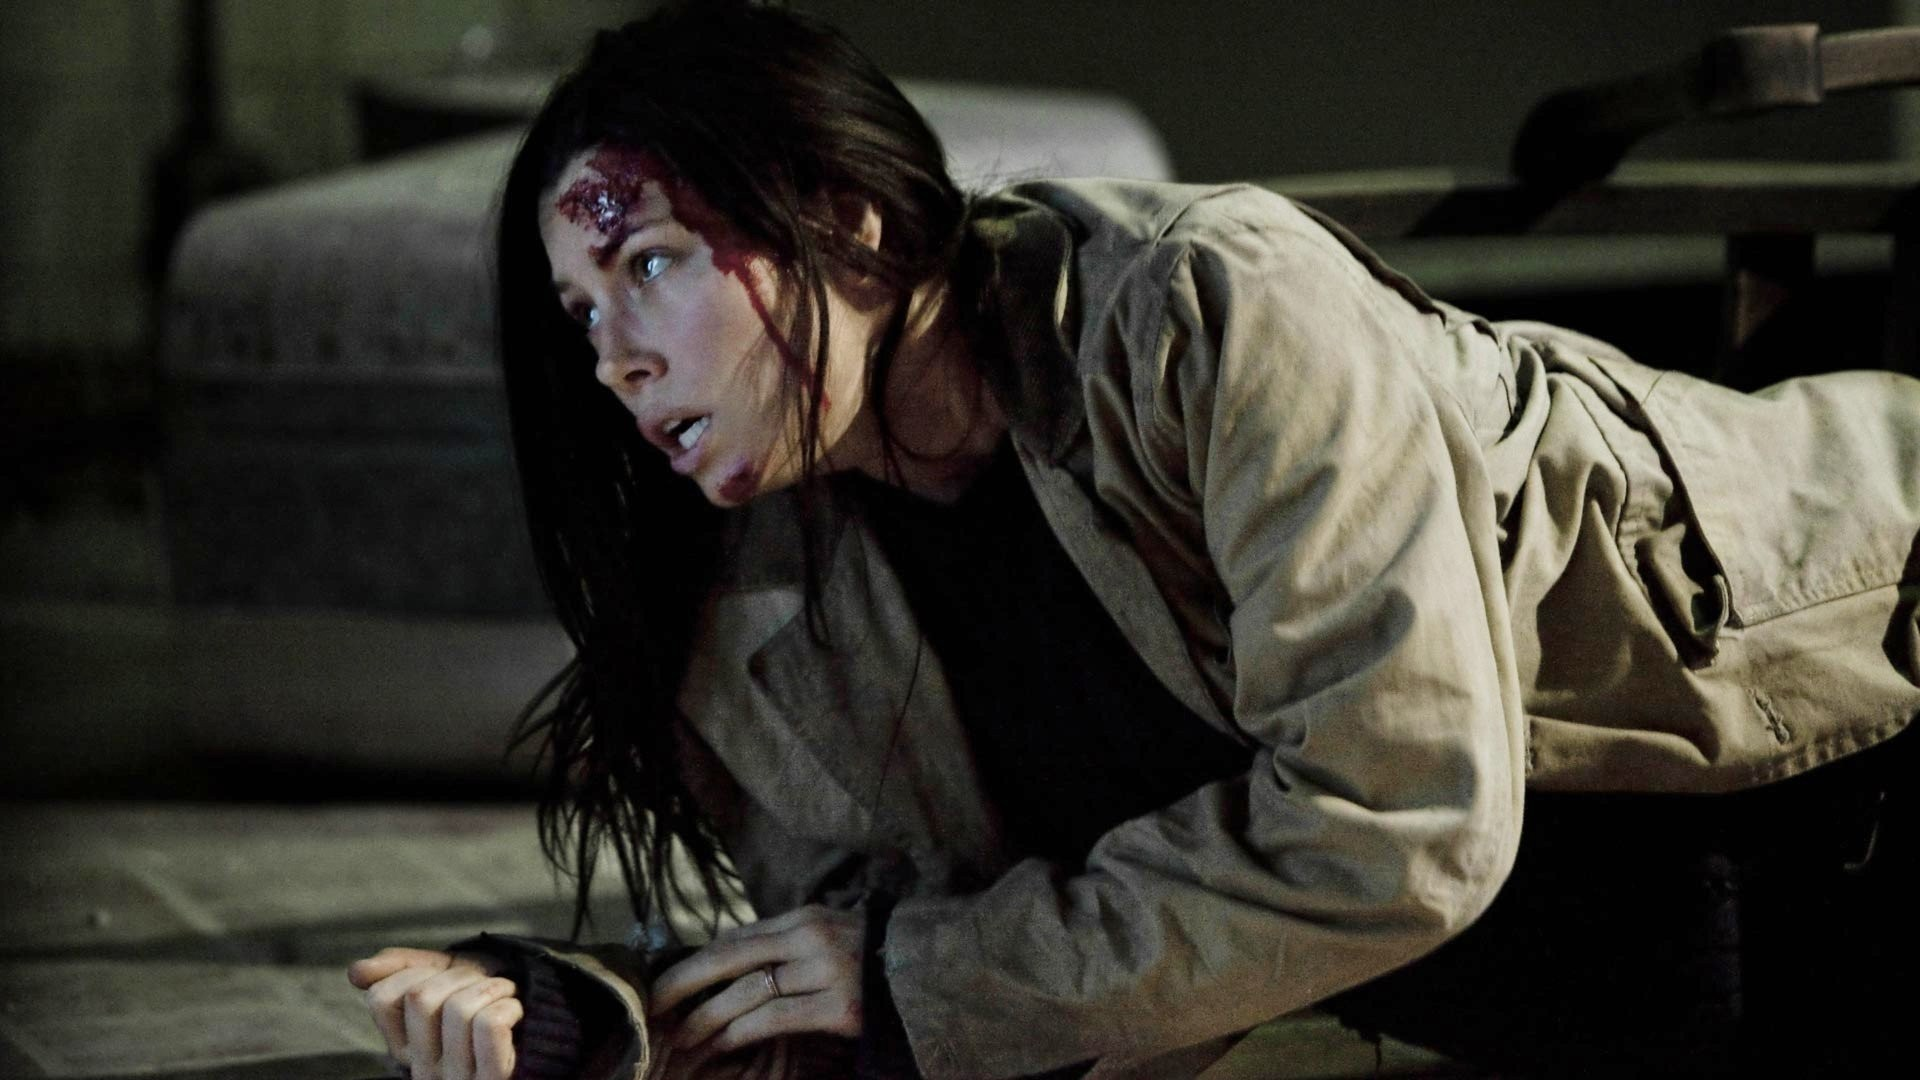Imagine this scene is from a sci-fi movie. What is the woman’s role in the story? In a sci-fi setting, the woman could be a rogue scientist or an ex-soldier who has crucial knowledge about a covert government experiment gone wrong. Having uncovered the dark truths of a secret facility experimenting with dangerous technologies, she's now on the run. The warehouse is actually an abandoned tech hub where she hopes to find a device that can help her expose the truth. Her injury is from a battle with robotic security units, and her expression reflects not just fear, but a relentless determination to reveal the truth to the world. 